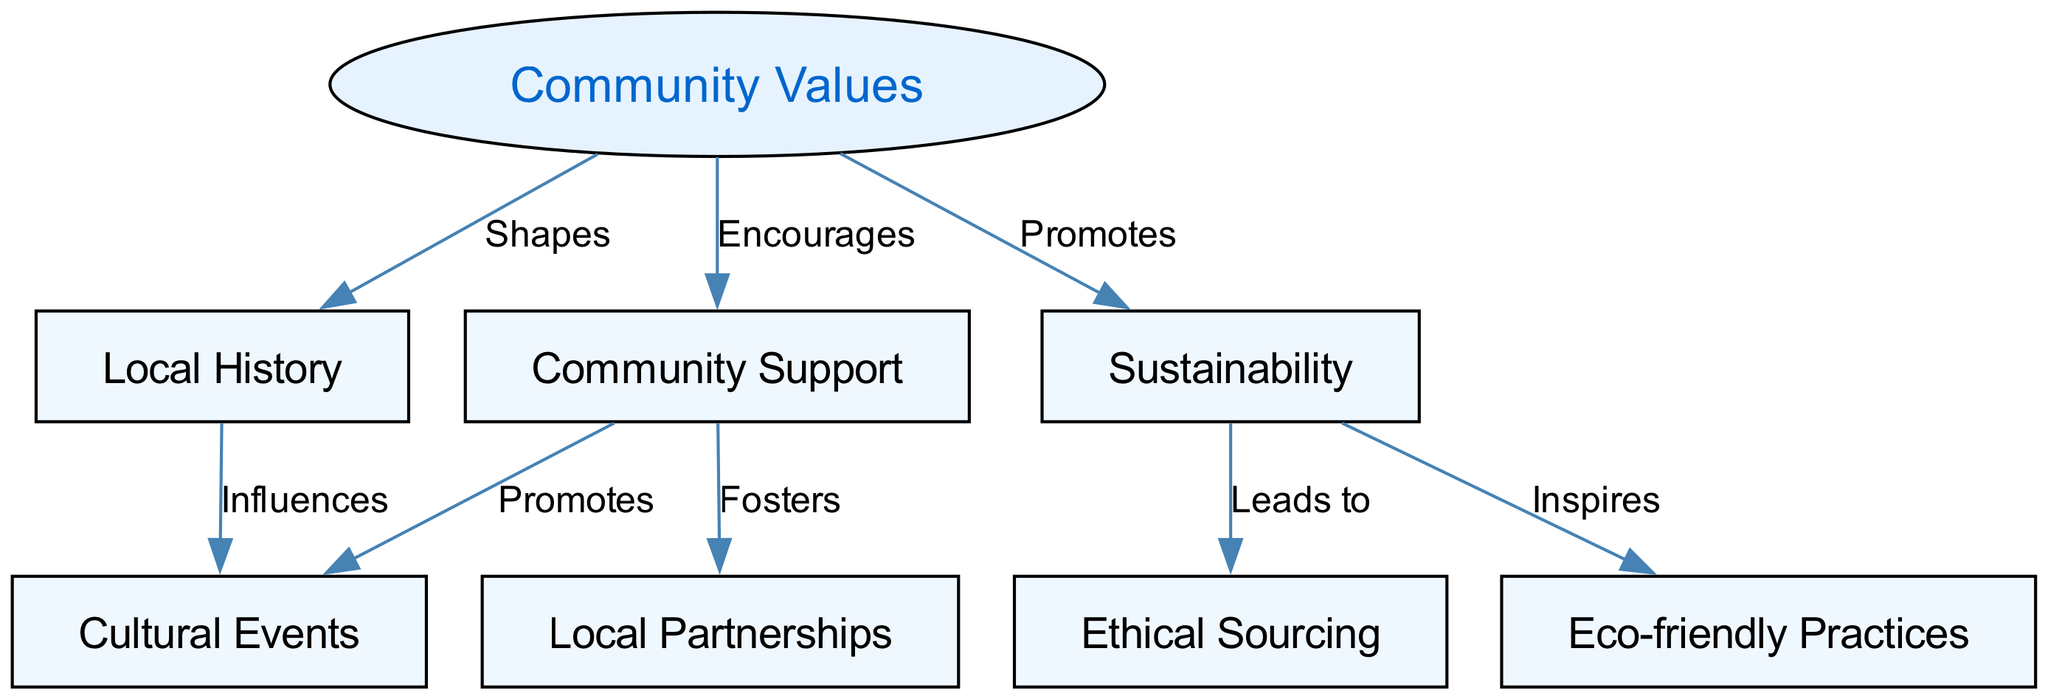What are the community values represented in the diagram? The diagram includes nodes like "Local History," "Sustainability," "Community Support," "Ethical Sourcing," "Local Partnerships," "Eco-friendly Practices," and "Cultural Events." Each of these represents a key community value.
Answer: Local History, Sustainability, Community Support, Ethical Sourcing, Local Partnerships, Eco-friendly Practices, Cultural Events How many nodes are there in the diagram? Counting the nodes listed, we find a total of 8 individual nodes: "Community Values," "Local History," "Sustainability," "Community Support," "Ethical Sourcing," "Local Partnerships," "Eco-friendly Practices," and "Cultural Events."
Answer: 8 What does "Sustainability" promote in the diagram? According to the diagram connections, "Sustainability" promotes "Community Support," demonstrating its encouraging role in the community values structure.
Answer: Community Support Which node influences "Cultural Events"? The diagram indicates that "Local History" influences "Cultural Events," connecting cultural heritage with community gatherings.
Answer: Local History What relationship exists between "Sustainability" and "Ethical Sourcing"? The diagram shows that "Sustainability" leads to "Ethical Sourcing," highlighting the connection between practices aimed at protecting the environment and the sourcing of materials.
Answer: Leads to How does "Community Support" affect local engagement? "Community Support" fosters "Local Partnerships" and promotes "Cultural Events," indicating it's a central theme that enhances local connectivity and community engagement through partnerships and events.
Answer: Fosters, Promotes What is the overall influence of community values on local partnerships? The diagram illustrates that "Community Values" shape "Local Partnerships" through community support, indicating the significant impact of these values on developing relationships in the community.
Answer: Shapes What type of practices does sustainability inspire according to the diagram? The connection shows that "Sustainability" inspires "Eco-friendly Practices," suggesting that sustainable ideals can lead businesses to adopt more environmentally responsible actions.
Answer: Eco-friendly Practices 